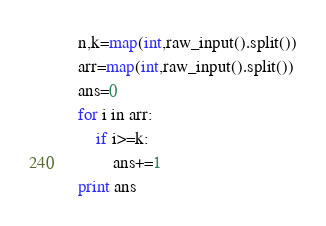<code> <loc_0><loc_0><loc_500><loc_500><_Python_>n,k=map(int,raw_input().split())
arr=map(int,raw_input().split())
ans=0
for i in arr:
    if i>=k:
        ans+=1
print ans
</code> 